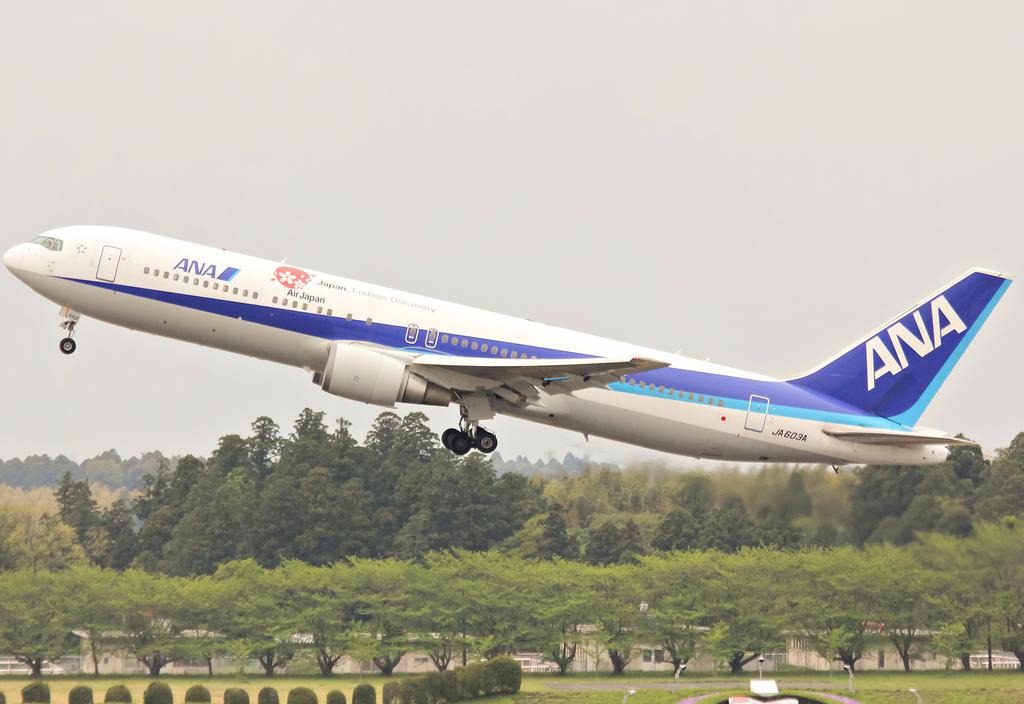What is the main subject of the image? The main subject of the image is an airplane flying. What type of natural environment can be seen in the image? There are trees visible in the image. What type of structures are present in the image? There are sheds in the image. What is visible in the background of the image? The sky is visible in the background of the image. Can you tell me how many porters are assisting the passengers in the image? There is no reference to porters or passengers in the image; it only shows an airplane flying, trees, sheds, and the sky. 